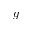<formula> <loc_0><loc_0><loc_500><loc_500>g</formula> 